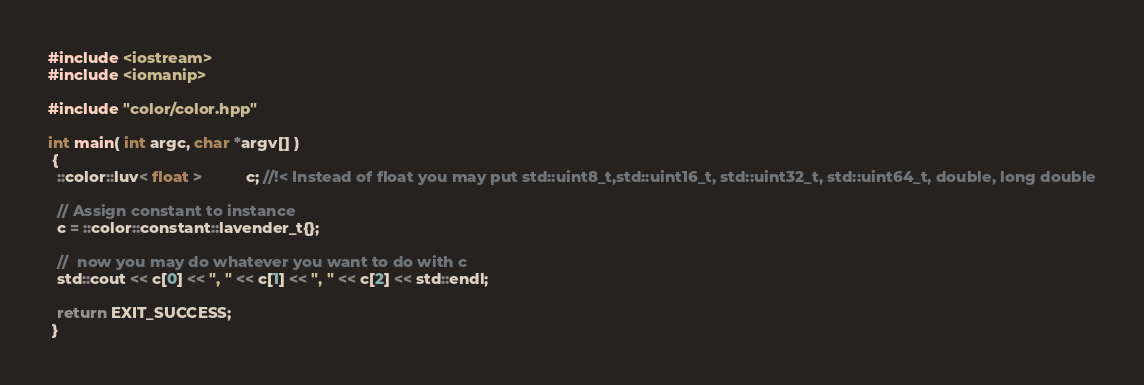Convert code to text. <code><loc_0><loc_0><loc_500><loc_500><_C++_>#include <iostream>
#include <iomanip>

#include "color/color.hpp"

int main( int argc, char *argv[] )
 {
  ::color::luv< float >          c; //!< Instead of float you may put std::uint8_t,std::uint16_t, std::uint32_t, std::uint64_t, double, long double

  // Assign constant to instance
  c = ::color::constant::lavender_t{};

  //  now you may do whatever you want to do with c
  std::cout << c[0] << ", " << c[1] << ", " << c[2] << std::endl;

  return EXIT_SUCCESS;
 }
</code> 